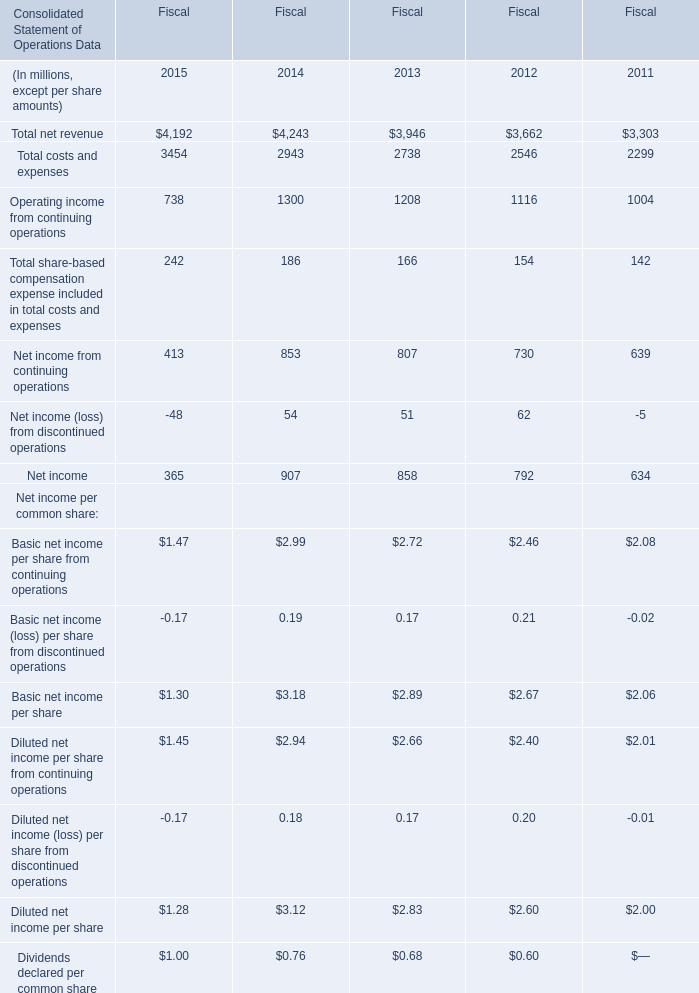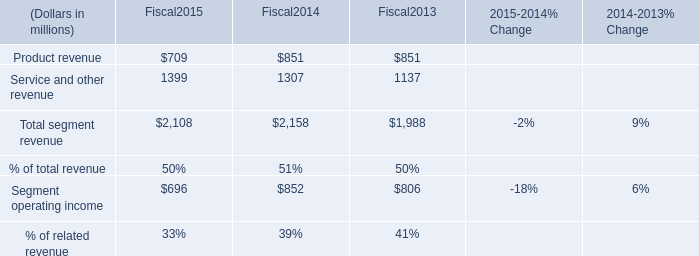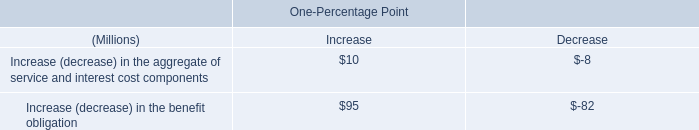Does Total net revenue keeps increasing each year between 2015 and 2014? 
Answer: No. 